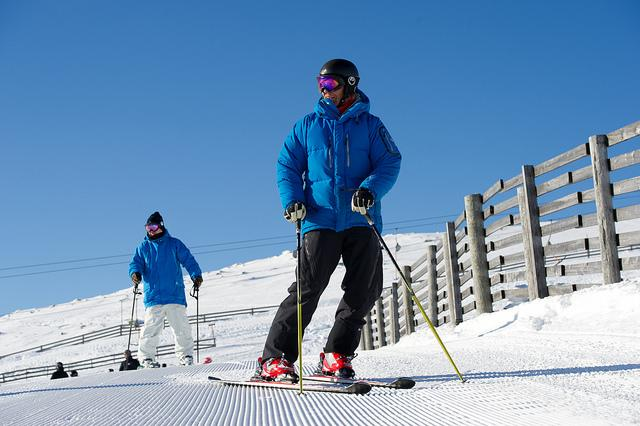What made the grooves seen here? rake 